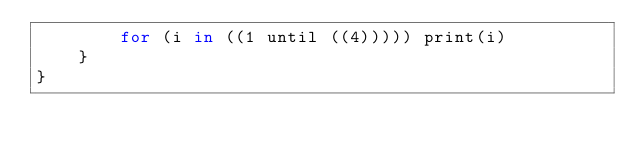Convert code to text. <code><loc_0><loc_0><loc_500><loc_500><_Kotlin_>        for (i in ((1 until ((4))))) print(i)
    }
}</code> 